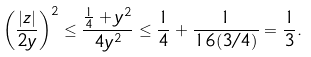<formula> <loc_0><loc_0><loc_500><loc_500>\left ( \frac { | z | } { 2 y } \right ) ^ { 2 } \leq \frac { \frac { 1 } { 4 } + y ^ { 2 } } { 4 y ^ { 2 } } \leq \frac { 1 } { 4 } + \frac { 1 } { 1 6 ( 3 / 4 ) } = \frac { 1 } { 3 } .</formula> 